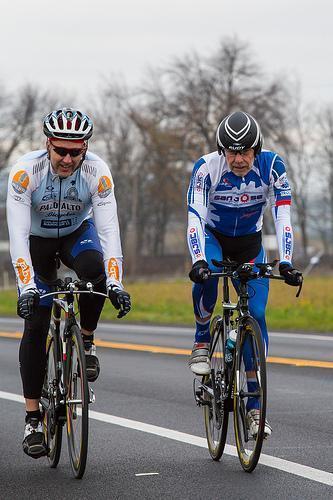How many cycle?
Give a very brief answer. 2. 